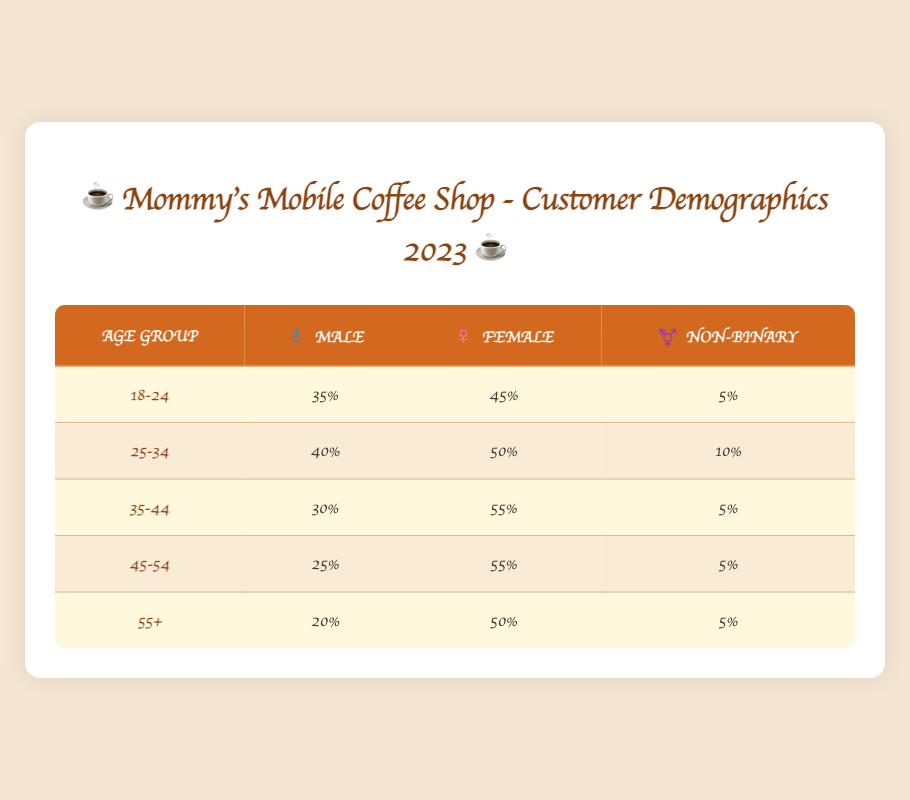What is the percentage of female customers in the 25-34 age group? In the 25-34 age group, the table shows 50% female customers.
Answer: 50% Which age group has the highest percentage of male customers? The 25-34 age group has the highest percentage of male customers at 40%.
Answer: 25-34 How many non-binary customers are there in the 35-44 age group? The table shows that there are 5% non-binary customers in the 35-44 age group.
Answer: 5% What is the total percentage of male customers across all age groups? Adding the male percentages: 35 + 40 + 30 + 25 + 20 = 150%. Therefore, the total percentage of male customers is 150%.
Answer: 150% Is it true that there are more female customers in the 45-54 age group than in the 18-24 age group? Yes, the 45-54 age group has 55% female customers, while the 18-24 age group has 45%.
Answer: Yes What is the difference in percentage of male customers between the 18-24 and 55+ age groups? The percentage of male customers is 35% for 18-24 and 20% for 55+, so the difference is 35 - 20 = 15%.
Answer: 15% Which age group has the lowest percentage of female customers? The 55+ age group has the lowest percentage of female customers at 50%.
Answer: 55+ What is the average percentage of non-binary customers across all age groups? The non-binary percentages are 5, 10, 5, 5, and 5. The sum is 30; dividing by 5 gives an average of 30/5 = 6%.
Answer: 6% How many total customers are male in all age groups combined? The total count of male customers is 35 + 40 + 30 + 25 + 20 = 150%.
Answer: 150% In which age group does the ratio of female customers to male customers appear to be the most balanced? The 25-34 age group has 50% female and 40% male, indicating a balanced ratio as the numbers are closest.
Answer: 25-34 